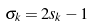<formula> <loc_0><loc_0><loc_500><loc_500>\sigma _ { k } = 2 s _ { k } - 1</formula> 